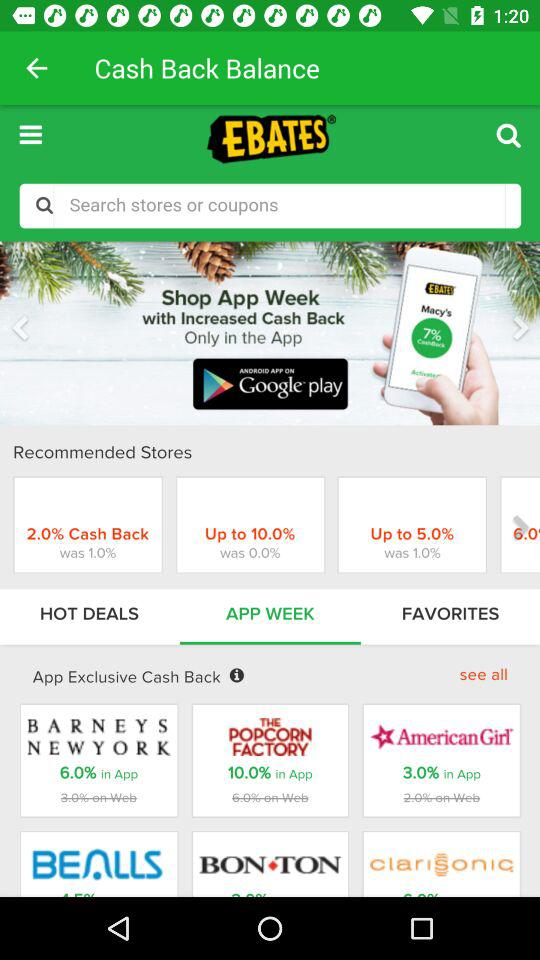How much app-exclusive cashback is there for "THE POPCORN FACTORY"? There is 10% app-exclusive cashback for "THE POPCORN FACTORY". 